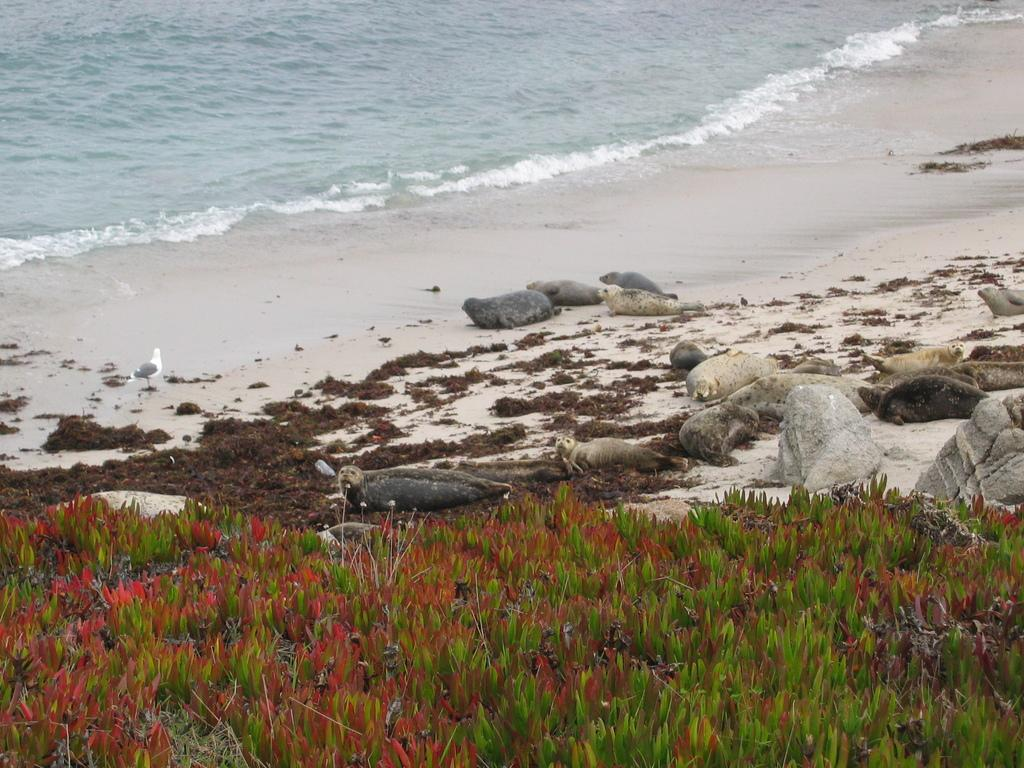What type of living organisms can be seen in the image? Plants and animals are visible in the image. Where are the animals located in the image? The animals are on the sand in the image. What type of bird is present in the image? There is a bird in the image. What is in front of the animals in the image? There is water in front of the animals in the image. What type of muscle is being exercised by the animals in the image? There is no indication in the image that the animals are exercising any muscles, so it cannot be determined from the picture. 